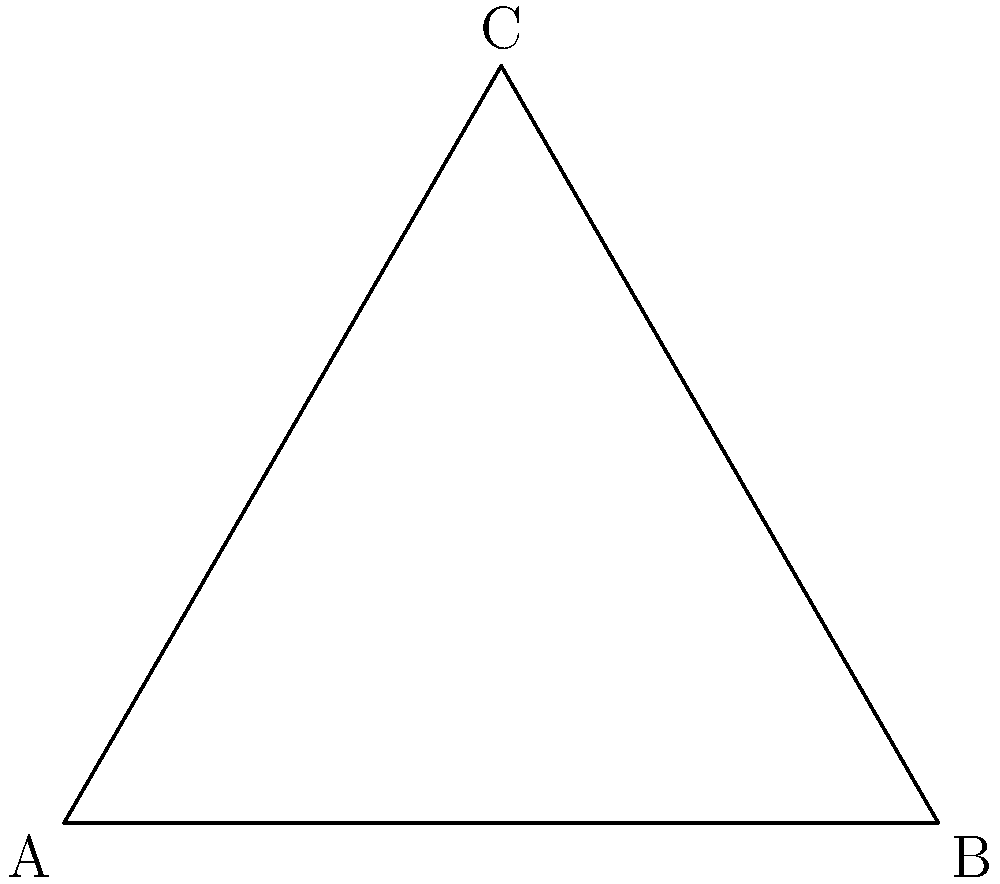As an app developer, you're designing a mobile interface and need to determine the optimal viewing angle. Given that the average human field of vision is represented by an equilateral triangle, with a $60°$ angle at each vertex, what is the ideal angle for positioning UI elements to ensure maximum visibility without causing eye strain? To determine the optimal viewing angle for UI elements in a mobile app interface, we need to consider the properties of an equilateral triangle and human ergonomics:

1. In an equilateral triangle, all angles are equal and measure $60°$.

2. The sum of angles in a triangle is always $180°$.

3. The perpendicular bisector of any side of an equilateral triangle passes through the opposite vertex and divides the angle at that vertex into two equal parts.

4. This perpendicular bisector creates two $30°$ angles with the base of the triangle.

5. The $30°$ angle is significant in ergonomics as it represents a comfortable viewing angle for the human eye without causing strain.

6. The complementary angle to $30°$ is $60°$, which aligns with the natural angle of the equilateral triangle representing the human field of vision.

7. Therefore, positioning UI elements within a $60°$ arc centered on the perpendicular bisector (or $30°$ on either side of it) would provide optimal visibility and comfort for users.

This angle ensures that the elements are within the user's natural field of vision and can be viewed without excessive eye or neck movement, reducing fatigue during prolonged use of the app.
Answer: $60°$ (centered on the perpendicular bisector) 